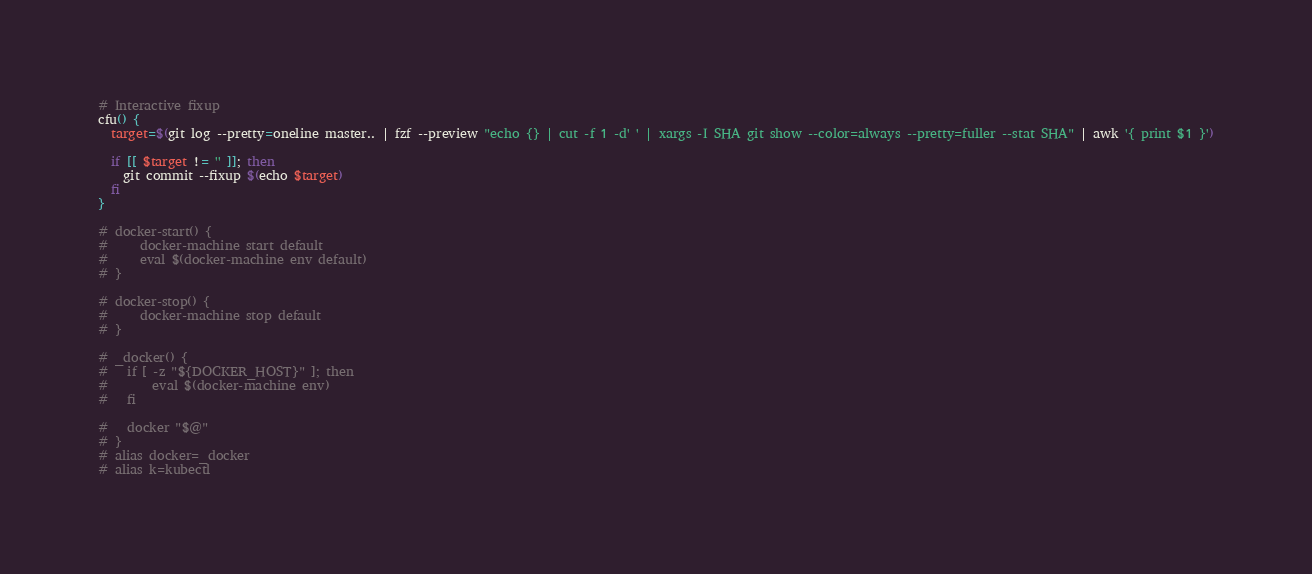Convert code to text. <code><loc_0><loc_0><loc_500><loc_500><_Bash_>
# Interactive fixup
cfu() {
  target=$(git log --pretty=oneline master.. | fzf --preview "echo {} | cut -f 1 -d' ' | xargs -I SHA git show --color=always --pretty=fuller --stat SHA" | awk '{ print $1 }')

  if [[ $target != '' ]]; then
    git commit --fixup $(echo $target)
  fi
}

# docker-start() {
#     docker-machine start default
#     eval $(docker-machine env default)
# }

# docker-stop() {
#     docker-machine stop default
# }

# _docker() {
# 	if [ -z "${DOCKER_HOST}" ]; then
# 		eval $(docker-machine env)
# 	fi

# 	docker "$@"
# }
# alias docker=_docker
# alias k=kubectl
</code> 